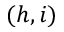<formula> <loc_0><loc_0><loc_500><loc_500>( h , i )</formula> 